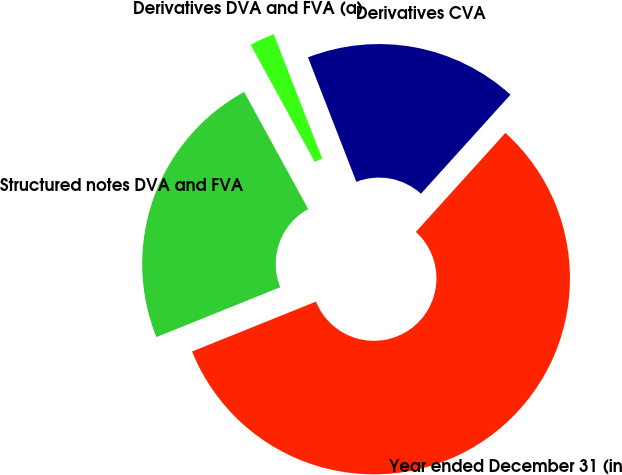Convert chart to OTSL. <chart><loc_0><loc_0><loc_500><loc_500><pie_chart><fcel>Year ended December 31 (in<fcel>Derivatives CVA<fcel>Derivatives DVA and FVA (a)<fcel>Structured notes DVA and FVA<nl><fcel>57.21%<fcel>17.6%<fcel>2.07%<fcel>23.12%<nl></chart> 